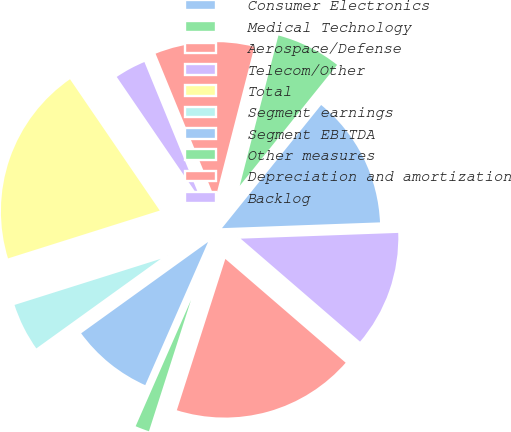<chart> <loc_0><loc_0><loc_500><loc_500><pie_chart><fcel>Consumer Electronics<fcel>Medical Technology<fcel>Aerospace/Defense<fcel>Telecom/Other<fcel>Total<fcel>Segment earnings<fcel>Segment EBITDA<fcel>Other measures<fcel>Depreciation and amortization<fcel>Backlog<nl><fcel>13.63%<fcel>6.78%<fcel>10.2%<fcel>3.35%<fcel>20.32%<fcel>5.07%<fcel>8.49%<fcel>1.64%<fcel>18.61%<fcel>11.91%<nl></chart> 